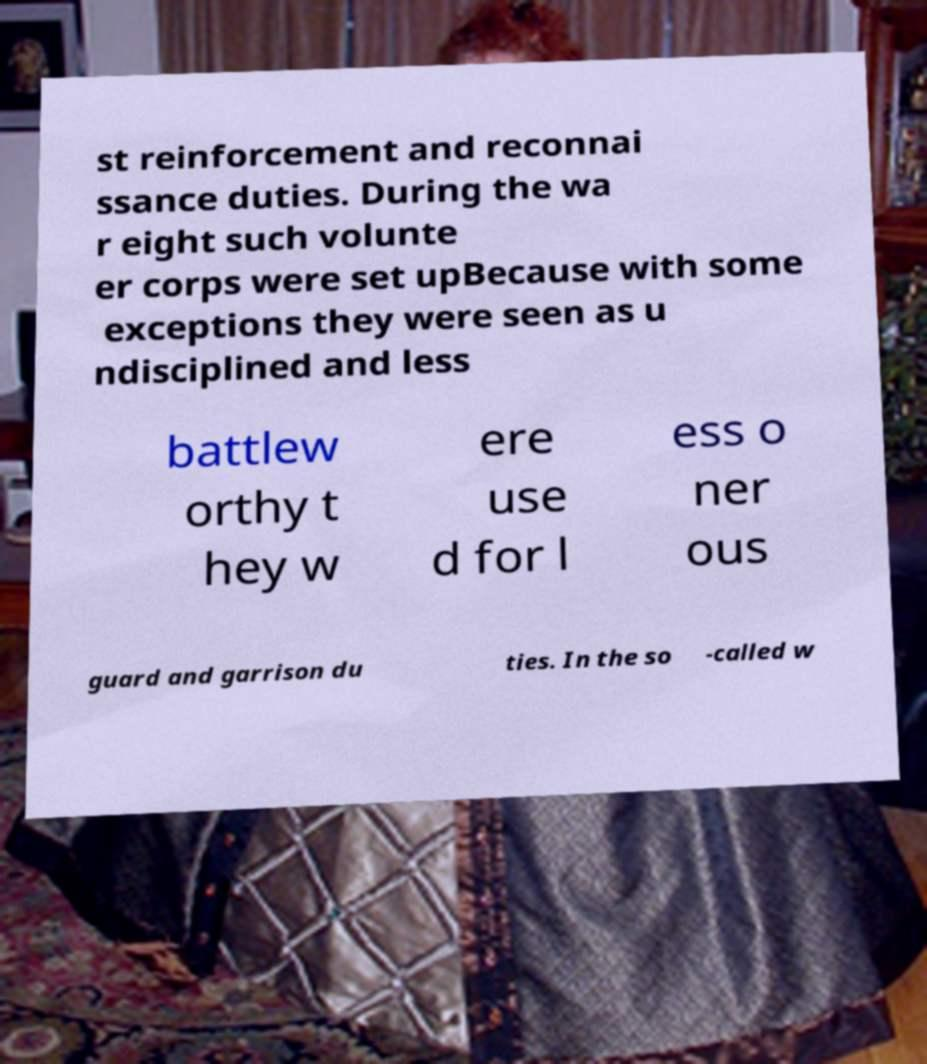Please identify and transcribe the text found in this image. st reinforcement and reconnai ssance duties. During the wa r eight such volunte er corps were set upBecause with some exceptions they were seen as u ndisciplined and less battlew orthy t hey w ere use d for l ess o ner ous guard and garrison du ties. In the so -called w 